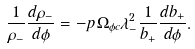Convert formula to latex. <formula><loc_0><loc_0><loc_500><loc_500>\frac { 1 } { \rho _ { - } } \frac { d \rho _ { - } } { d \phi } = - p \Omega _ { \phi c } \lambda _ { - } ^ { 2 } \frac { 1 } { b _ { + } } \frac { d b _ { + } } { d \phi } .</formula> 